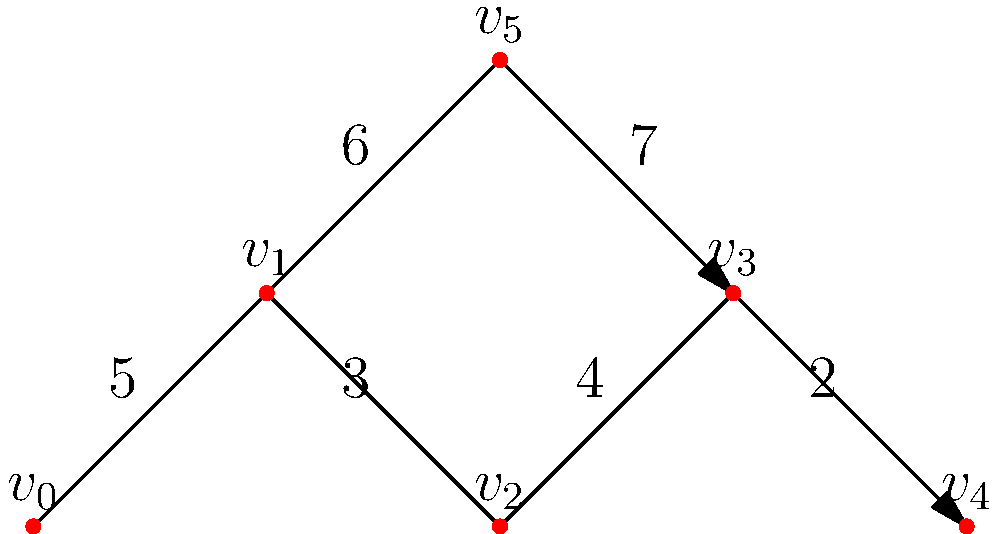As a farmer in Ludhiana, you're planning an irrigation system for nearby farmlands. The water distribution network is represented by the graph above, where vertices are connection points and edge weights represent the cost (in lakh rupees) to build water channels between points. What is the minimum cost to connect all points in the network? To find the minimum cost to connect all points, we need to find the Minimum Spanning Tree (MST) of the given graph. We can use Kruskal's algorithm to solve this:

1. Sort all edges by weight in ascending order:
   $(v_3, v_4)$: 2
   $(v_1, v_2)$: 3
   $(v_2, v_3)$: 4
   $(v_0, v_1)$: 5
   $(v_1, v_5)$: 6
   $(v_5, v_3)$: 7

2. Start with an empty MST and add edges in order, skipping those that would create a cycle:
   - Add $(v_3, v_4)$: Cost = 2
   - Add $(v_1, v_2)$: Cost = 2 + 3 = 5
   - Add $(v_2, v_3)$: Cost = 5 + 4 = 9
   - Add $(v_0, v_1)$: Cost = 9 + 5 = 14

3. We've now connected all vertices, so we stop here.

The minimum cost to connect all points is the sum of the weights of the edges in the MST: 14 lakh rupees.
Answer: 14 lakh rupees 